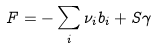Convert formula to latex. <formula><loc_0><loc_0><loc_500><loc_500>F = - \sum _ { i } \nu _ { i } b _ { i } + S \gamma</formula> 